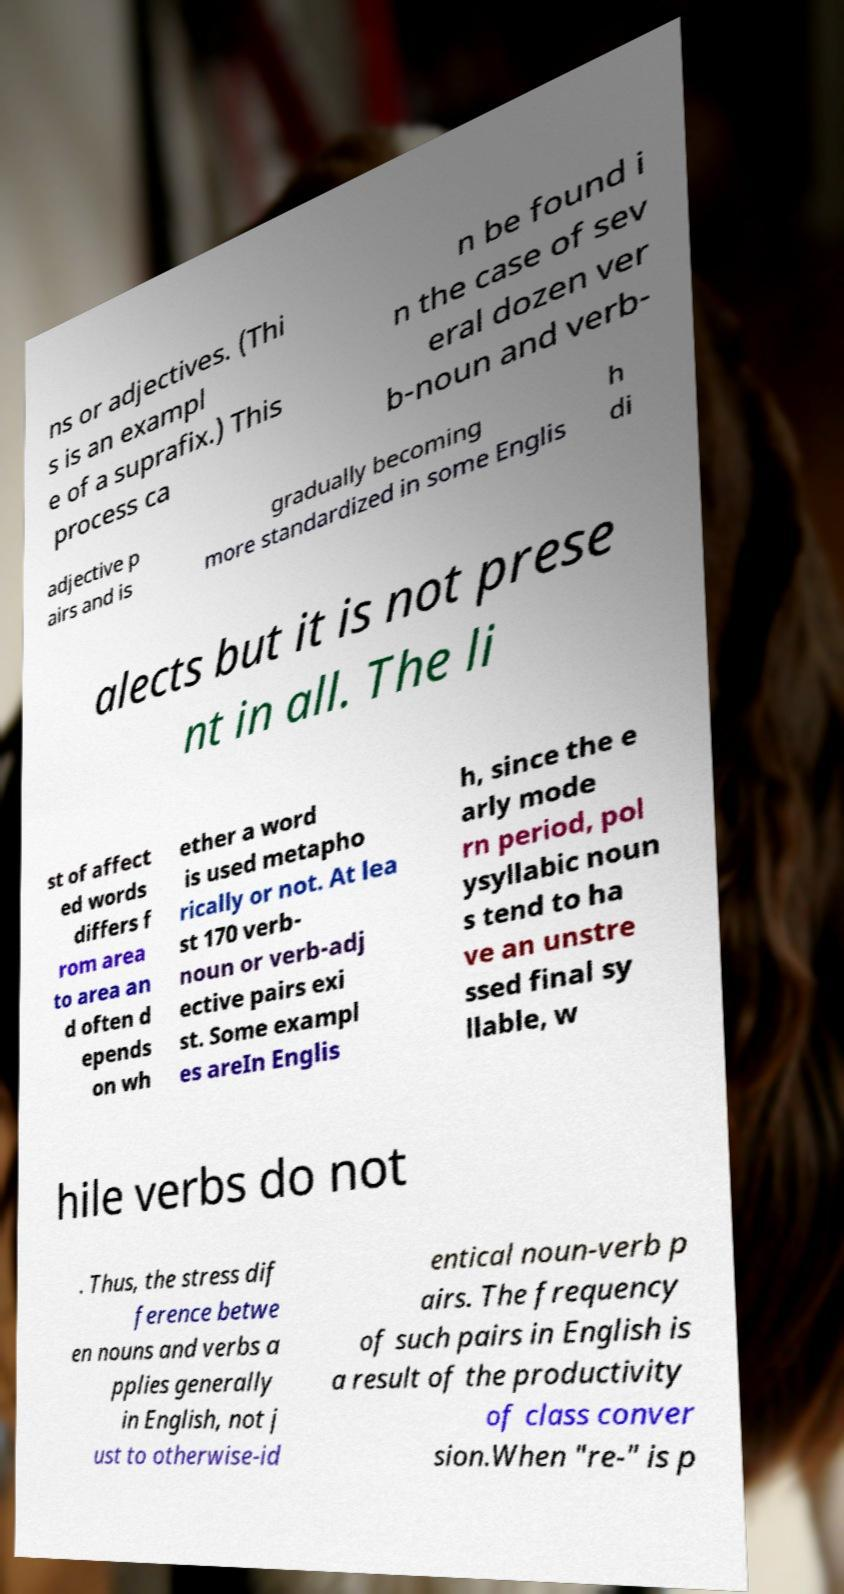For documentation purposes, I need the text within this image transcribed. Could you provide that? ns or adjectives. (Thi s is an exampl e of a suprafix.) This process ca n be found i n the case of sev eral dozen ver b-noun and verb- adjective p airs and is gradually becoming more standardized in some Englis h di alects but it is not prese nt in all. The li st of affect ed words differs f rom area to area an d often d epends on wh ether a word is used metapho rically or not. At lea st 170 verb- noun or verb-adj ective pairs exi st. Some exampl es areIn Englis h, since the e arly mode rn period, pol ysyllabic noun s tend to ha ve an unstre ssed final sy llable, w hile verbs do not . Thus, the stress dif ference betwe en nouns and verbs a pplies generally in English, not j ust to otherwise-id entical noun-verb p airs. The frequency of such pairs in English is a result of the productivity of class conver sion.When "re-" is p 